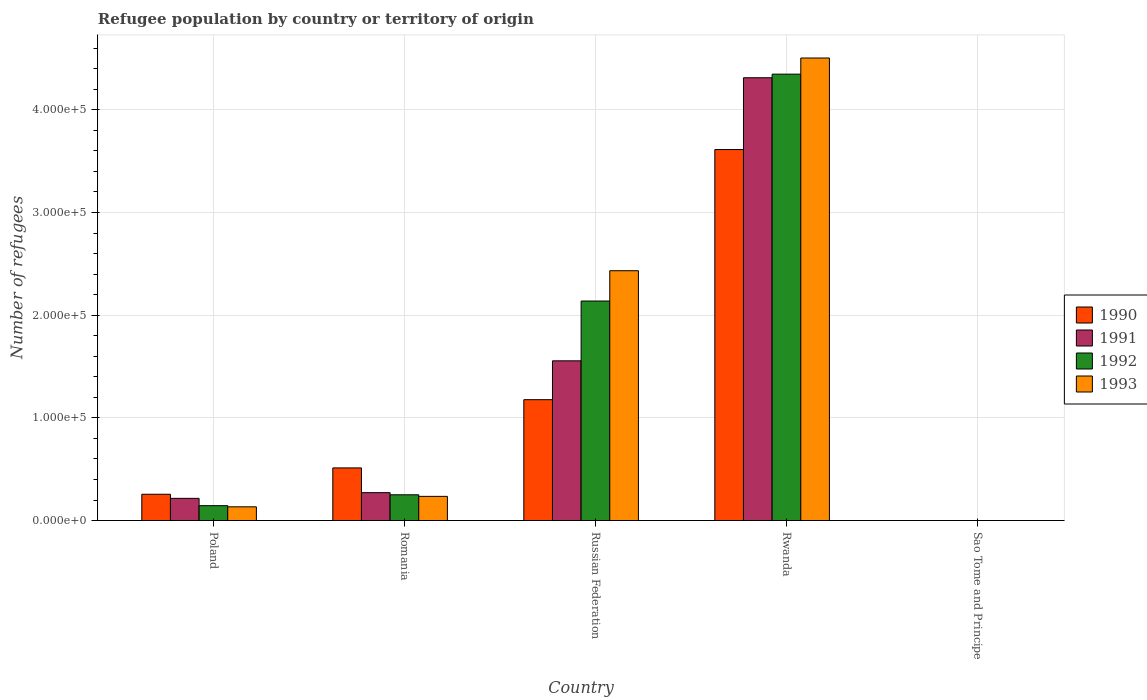How many groups of bars are there?
Your answer should be compact. 5. Are the number of bars on each tick of the X-axis equal?
Offer a terse response. Yes. How many bars are there on the 1st tick from the left?
Offer a terse response. 4. What is the label of the 3rd group of bars from the left?
Offer a very short reply. Russian Federation. In how many cases, is the number of bars for a given country not equal to the number of legend labels?
Offer a terse response. 0. What is the number of refugees in 1992 in Rwanda?
Your response must be concise. 4.35e+05. Across all countries, what is the maximum number of refugees in 1991?
Give a very brief answer. 4.31e+05. Across all countries, what is the minimum number of refugees in 1993?
Make the answer very short. 1. In which country was the number of refugees in 1990 maximum?
Make the answer very short. Rwanda. In which country was the number of refugees in 1992 minimum?
Offer a terse response. Sao Tome and Principe. What is the total number of refugees in 1990 in the graph?
Ensure brevity in your answer.  5.56e+05. What is the difference between the number of refugees in 1992 in Rwanda and that in Sao Tome and Principe?
Give a very brief answer. 4.35e+05. What is the difference between the number of refugees in 1993 in Poland and the number of refugees in 1992 in Sao Tome and Principe?
Your answer should be compact. 1.34e+04. What is the average number of refugees in 1993 per country?
Ensure brevity in your answer.  1.46e+05. What is the difference between the number of refugees of/in 1991 and number of refugees of/in 1990 in Poland?
Keep it short and to the point. -3989. What is the ratio of the number of refugees in 1993 in Poland to that in Sao Tome and Principe?
Your answer should be compact. 1.34e+04. Is the difference between the number of refugees in 1991 in Poland and Rwanda greater than the difference between the number of refugees in 1990 in Poland and Rwanda?
Keep it short and to the point. No. What is the difference between the highest and the second highest number of refugees in 1991?
Offer a very short reply. 4.04e+05. What is the difference between the highest and the lowest number of refugees in 1993?
Your response must be concise. 4.50e+05. In how many countries, is the number of refugees in 1990 greater than the average number of refugees in 1990 taken over all countries?
Provide a short and direct response. 2. What does the 4th bar from the left in Sao Tome and Principe represents?
Provide a short and direct response. 1993. How many bars are there?
Provide a succinct answer. 20. Where does the legend appear in the graph?
Offer a terse response. Center right. How many legend labels are there?
Offer a very short reply. 4. How are the legend labels stacked?
Offer a terse response. Vertical. What is the title of the graph?
Make the answer very short. Refugee population by country or territory of origin. Does "1974" appear as one of the legend labels in the graph?
Your response must be concise. No. What is the label or title of the Y-axis?
Keep it short and to the point. Number of refugees. What is the Number of refugees of 1990 in Poland?
Offer a terse response. 2.56e+04. What is the Number of refugees in 1991 in Poland?
Ensure brevity in your answer.  2.16e+04. What is the Number of refugees in 1992 in Poland?
Your answer should be very brief. 1.45e+04. What is the Number of refugees of 1993 in Poland?
Offer a terse response. 1.34e+04. What is the Number of refugees of 1990 in Romania?
Provide a short and direct response. 5.13e+04. What is the Number of refugees in 1991 in Romania?
Offer a terse response. 2.72e+04. What is the Number of refugees in 1992 in Romania?
Your answer should be compact. 2.51e+04. What is the Number of refugees of 1993 in Romania?
Your answer should be very brief. 2.36e+04. What is the Number of refugees in 1990 in Russian Federation?
Provide a short and direct response. 1.18e+05. What is the Number of refugees of 1991 in Russian Federation?
Provide a short and direct response. 1.56e+05. What is the Number of refugees in 1992 in Russian Federation?
Ensure brevity in your answer.  2.14e+05. What is the Number of refugees of 1993 in Russian Federation?
Offer a very short reply. 2.43e+05. What is the Number of refugees of 1990 in Rwanda?
Your answer should be very brief. 3.61e+05. What is the Number of refugees in 1991 in Rwanda?
Offer a terse response. 4.31e+05. What is the Number of refugees of 1992 in Rwanda?
Give a very brief answer. 4.35e+05. What is the Number of refugees in 1993 in Rwanda?
Make the answer very short. 4.50e+05. What is the Number of refugees in 1991 in Sao Tome and Principe?
Offer a very short reply. 1. What is the Number of refugees in 1992 in Sao Tome and Principe?
Provide a succinct answer. 1. Across all countries, what is the maximum Number of refugees in 1990?
Your response must be concise. 3.61e+05. Across all countries, what is the maximum Number of refugees of 1991?
Make the answer very short. 4.31e+05. Across all countries, what is the maximum Number of refugees in 1992?
Give a very brief answer. 4.35e+05. Across all countries, what is the maximum Number of refugees in 1993?
Your answer should be very brief. 4.50e+05. Across all countries, what is the minimum Number of refugees of 1990?
Your answer should be very brief. 1. Across all countries, what is the minimum Number of refugees in 1991?
Provide a succinct answer. 1. Across all countries, what is the minimum Number of refugees of 1992?
Offer a terse response. 1. What is the total Number of refugees in 1990 in the graph?
Provide a short and direct response. 5.56e+05. What is the total Number of refugees of 1991 in the graph?
Your response must be concise. 6.36e+05. What is the total Number of refugees in 1992 in the graph?
Provide a succinct answer. 6.88e+05. What is the total Number of refugees in 1993 in the graph?
Keep it short and to the point. 7.31e+05. What is the difference between the Number of refugees in 1990 in Poland and that in Romania?
Your response must be concise. -2.56e+04. What is the difference between the Number of refugees of 1991 in Poland and that in Romania?
Provide a short and direct response. -5534. What is the difference between the Number of refugees of 1992 in Poland and that in Romania?
Ensure brevity in your answer.  -1.06e+04. What is the difference between the Number of refugees in 1993 in Poland and that in Romania?
Provide a short and direct response. -1.02e+04. What is the difference between the Number of refugees in 1990 in Poland and that in Russian Federation?
Keep it short and to the point. -9.21e+04. What is the difference between the Number of refugees in 1991 in Poland and that in Russian Federation?
Your response must be concise. -1.34e+05. What is the difference between the Number of refugees of 1992 in Poland and that in Russian Federation?
Provide a short and direct response. -1.99e+05. What is the difference between the Number of refugees in 1993 in Poland and that in Russian Federation?
Your response must be concise. -2.30e+05. What is the difference between the Number of refugees in 1990 in Poland and that in Rwanda?
Provide a short and direct response. -3.36e+05. What is the difference between the Number of refugees of 1991 in Poland and that in Rwanda?
Your answer should be compact. -4.10e+05. What is the difference between the Number of refugees in 1992 in Poland and that in Rwanda?
Offer a very short reply. -4.20e+05. What is the difference between the Number of refugees of 1993 in Poland and that in Rwanda?
Your answer should be compact. -4.37e+05. What is the difference between the Number of refugees of 1990 in Poland and that in Sao Tome and Principe?
Your response must be concise. 2.56e+04. What is the difference between the Number of refugees of 1991 in Poland and that in Sao Tome and Principe?
Keep it short and to the point. 2.16e+04. What is the difference between the Number of refugees of 1992 in Poland and that in Sao Tome and Principe?
Offer a terse response. 1.45e+04. What is the difference between the Number of refugees in 1993 in Poland and that in Sao Tome and Principe?
Offer a terse response. 1.34e+04. What is the difference between the Number of refugees in 1990 in Romania and that in Russian Federation?
Provide a succinct answer. -6.65e+04. What is the difference between the Number of refugees in 1991 in Romania and that in Russian Federation?
Provide a short and direct response. -1.28e+05. What is the difference between the Number of refugees in 1992 in Romania and that in Russian Federation?
Ensure brevity in your answer.  -1.89e+05. What is the difference between the Number of refugees in 1993 in Romania and that in Russian Federation?
Provide a short and direct response. -2.20e+05. What is the difference between the Number of refugees of 1990 in Romania and that in Rwanda?
Your response must be concise. -3.10e+05. What is the difference between the Number of refugees in 1991 in Romania and that in Rwanda?
Provide a short and direct response. -4.04e+05. What is the difference between the Number of refugees of 1992 in Romania and that in Rwanda?
Provide a short and direct response. -4.10e+05. What is the difference between the Number of refugees of 1993 in Romania and that in Rwanda?
Keep it short and to the point. -4.27e+05. What is the difference between the Number of refugees of 1990 in Romania and that in Sao Tome and Principe?
Offer a terse response. 5.13e+04. What is the difference between the Number of refugees in 1991 in Romania and that in Sao Tome and Principe?
Ensure brevity in your answer.  2.72e+04. What is the difference between the Number of refugees of 1992 in Romania and that in Sao Tome and Principe?
Your response must be concise. 2.51e+04. What is the difference between the Number of refugees in 1993 in Romania and that in Sao Tome and Principe?
Make the answer very short. 2.36e+04. What is the difference between the Number of refugees in 1990 in Russian Federation and that in Rwanda?
Ensure brevity in your answer.  -2.44e+05. What is the difference between the Number of refugees in 1991 in Russian Federation and that in Rwanda?
Make the answer very short. -2.76e+05. What is the difference between the Number of refugees in 1992 in Russian Federation and that in Rwanda?
Offer a very short reply. -2.21e+05. What is the difference between the Number of refugees in 1993 in Russian Federation and that in Rwanda?
Offer a very short reply. -2.07e+05. What is the difference between the Number of refugees of 1990 in Russian Federation and that in Sao Tome and Principe?
Your response must be concise. 1.18e+05. What is the difference between the Number of refugees in 1991 in Russian Federation and that in Sao Tome and Principe?
Provide a short and direct response. 1.56e+05. What is the difference between the Number of refugees of 1992 in Russian Federation and that in Sao Tome and Principe?
Make the answer very short. 2.14e+05. What is the difference between the Number of refugees in 1993 in Russian Federation and that in Sao Tome and Principe?
Your response must be concise. 2.43e+05. What is the difference between the Number of refugees in 1990 in Rwanda and that in Sao Tome and Principe?
Offer a terse response. 3.61e+05. What is the difference between the Number of refugees of 1991 in Rwanda and that in Sao Tome and Principe?
Offer a very short reply. 4.31e+05. What is the difference between the Number of refugees in 1992 in Rwanda and that in Sao Tome and Principe?
Your response must be concise. 4.35e+05. What is the difference between the Number of refugees in 1993 in Rwanda and that in Sao Tome and Principe?
Make the answer very short. 4.50e+05. What is the difference between the Number of refugees of 1990 in Poland and the Number of refugees of 1991 in Romania?
Provide a succinct answer. -1545. What is the difference between the Number of refugees of 1990 in Poland and the Number of refugees of 1992 in Romania?
Make the answer very short. 514. What is the difference between the Number of refugees of 1990 in Poland and the Number of refugees of 1993 in Romania?
Keep it short and to the point. 2060. What is the difference between the Number of refugees of 1991 in Poland and the Number of refugees of 1992 in Romania?
Provide a short and direct response. -3475. What is the difference between the Number of refugees of 1991 in Poland and the Number of refugees of 1993 in Romania?
Your answer should be very brief. -1929. What is the difference between the Number of refugees in 1992 in Poland and the Number of refugees in 1993 in Romania?
Provide a short and direct response. -9054. What is the difference between the Number of refugees of 1990 in Poland and the Number of refugees of 1991 in Russian Federation?
Your answer should be compact. -1.30e+05. What is the difference between the Number of refugees of 1990 in Poland and the Number of refugees of 1992 in Russian Federation?
Keep it short and to the point. -1.88e+05. What is the difference between the Number of refugees in 1990 in Poland and the Number of refugees in 1993 in Russian Federation?
Offer a very short reply. -2.18e+05. What is the difference between the Number of refugees of 1991 in Poland and the Number of refugees of 1992 in Russian Federation?
Ensure brevity in your answer.  -1.92e+05. What is the difference between the Number of refugees of 1991 in Poland and the Number of refugees of 1993 in Russian Federation?
Keep it short and to the point. -2.22e+05. What is the difference between the Number of refugees of 1992 in Poland and the Number of refugees of 1993 in Russian Federation?
Your answer should be compact. -2.29e+05. What is the difference between the Number of refugees of 1990 in Poland and the Number of refugees of 1991 in Rwanda?
Offer a terse response. -4.06e+05. What is the difference between the Number of refugees of 1990 in Poland and the Number of refugees of 1992 in Rwanda?
Offer a very short reply. -4.09e+05. What is the difference between the Number of refugees of 1990 in Poland and the Number of refugees of 1993 in Rwanda?
Offer a terse response. -4.25e+05. What is the difference between the Number of refugees of 1991 in Poland and the Number of refugees of 1992 in Rwanda?
Give a very brief answer. -4.13e+05. What is the difference between the Number of refugees of 1991 in Poland and the Number of refugees of 1993 in Rwanda?
Your answer should be very brief. -4.29e+05. What is the difference between the Number of refugees of 1992 in Poland and the Number of refugees of 1993 in Rwanda?
Give a very brief answer. -4.36e+05. What is the difference between the Number of refugees of 1990 in Poland and the Number of refugees of 1991 in Sao Tome and Principe?
Your answer should be compact. 2.56e+04. What is the difference between the Number of refugees of 1990 in Poland and the Number of refugees of 1992 in Sao Tome and Principe?
Your answer should be compact. 2.56e+04. What is the difference between the Number of refugees in 1990 in Poland and the Number of refugees in 1993 in Sao Tome and Principe?
Provide a succinct answer. 2.56e+04. What is the difference between the Number of refugees of 1991 in Poland and the Number of refugees of 1992 in Sao Tome and Principe?
Offer a very short reply. 2.16e+04. What is the difference between the Number of refugees in 1991 in Poland and the Number of refugees in 1993 in Sao Tome and Principe?
Keep it short and to the point. 2.16e+04. What is the difference between the Number of refugees of 1992 in Poland and the Number of refugees of 1993 in Sao Tome and Principe?
Keep it short and to the point. 1.45e+04. What is the difference between the Number of refugees of 1990 in Romania and the Number of refugees of 1991 in Russian Federation?
Your response must be concise. -1.04e+05. What is the difference between the Number of refugees in 1990 in Romania and the Number of refugees in 1992 in Russian Federation?
Give a very brief answer. -1.63e+05. What is the difference between the Number of refugees in 1990 in Romania and the Number of refugees in 1993 in Russian Federation?
Provide a short and direct response. -1.92e+05. What is the difference between the Number of refugees in 1991 in Romania and the Number of refugees in 1992 in Russian Federation?
Offer a terse response. -1.87e+05. What is the difference between the Number of refugees of 1991 in Romania and the Number of refugees of 1993 in Russian Federation?
Your answer should be very brief. -2.16e+05. What is the difference between the Number of refugees of 1992 in Romania and the Number of refugees of 1993 in Russian Federation?
Provide a succinct answer. -2.18e+05. What is the difference between the Number of refugees in 1990 in Romania and the Number of refugees in 1991 in Rwanda?
Ensure brevity in your answer.  -3.80e+05. What is the difference between the Number of refugees in 1990 in Romania and the Number of refugees in 1992 in Rwanda?
Your answer should be very brief. -3.83e+05. What is the difference between the Number of refugees in 1990 in Romania and the Number of refugees in 1993 in Rwanda?
Offer a terse response. -3.99e+05. What is the difference between the Number of refugees of 1991 in Romania and the Number of refugees of 1992 in Rwanda?
Your response must be concise. -4.08e+05. What is the difference between the Number of refugees in 1991 in Romania and the Number of refugees in 1993 in Rwanda?
Provide a short and direct response. -4.23e+05. What is the difference between the Number of refugees of 1992 in Romania and the Number of refugees of 1993 in Rwanda?
Your answer should be very brief. -4.25e+05. What is the difference between the Number of refugees in 1990 in Romania and the Number of refugees in 1991 in Sao Tome and Principe?
Make the answer very short. 5.13e+04. What is the difference between the Number of refugees in 1990 in Romania and the Number of refugees in 1992 in Sao Tome and Principe?
Offer a very short reply. 5.13e+04. What is the difference between the Number of refugees in 1990 in Romania and the Number of refugees in 1993 in Sao Tome and Principe?
Give a very brief answer. 5.13e+04. What is the difference between the Number of refugees of 1991 in Romania and the Number of refugees of 1992 in Sao Tome and Principe?
Give a very brief answer. 2.72e+04. What is the difference between the Number of refugees of 1991 in Romania and the Number of refugees of 1993 in Sao Tome and Principe?
Offer a terse response. 2.72e+04. What is the difference between the Number of refugees of 1992 in Romania and the Number of refugees of 1993 in Sao Tome and Principe?
Provide a succinct answer. 2.51e+04. What is the difference between the Number of refugees in 1990 in Russian Federation and the Number of refugees in 1991 in Rwanda?
Ensure brevity in your answer.  -3.14e+05. What is the difference between the Number of refugees of 1990 in Russian Federation and the Number of refugees of 1992 in Rwanda?
Provide a short and direct response. -3.17e+05. What is the difference between the Number of refugees in 1990 in Russian Federation and the Number of refugees in 1993 in Rwanda?
Offer a terse response. -3.33e+05. What is the difference between the Number of refugees of 1991 in Russian Federation and the Number of refugees of 1992 in Rwanda?
Provide a short and direct response. -2.79e+05. What is the difference between the Number of refugees of 1991 in Russian Federation and the Number of refugees of 1993 in Rwanda?
Ensure brevity in your answer.  -2.95e+05. What is the difference between the Number of refugees in 1992 in Russian Federation and the Number of refugees in 1993 in Rwanda?
Give a very brief answer. -2.37e+05. What is the difference between the Number of refugees of 1990 in Russian Federation and the Number of refugees of 1991 in Sao Tome and Principe?
Your response must be concise. 1.18e+05. What is the difference between the Number of refugees of 1990 in Russian Federation and the Number of refugees of 1992 in Sao Tome and Principe?
Your answer should be very brief. 1.18e+05. What is the difference between the Number of refugees in 1990 in Russian Federation and the Number of refugees in 1993 in Sao Tome and Principe?
Provide a short and direct response. 1.18e+05. What is the difference between the Number of refugees in 1991 in Russian Federation and the Number of refugees in 1992 in Sao Tome and Principe?
Give a very brief answer. 1.56e+05. What is the difference between the Number of refugees in 1991 in Russian Federation and the Number of refugees in 1993 in Sao Tome and Principe?
Keep it short and to the point. 1.56e+05. What is the difference between the Number of refugees in 1992 in Russian Federation and the Number of refugees in 1993 in Sao Tome and Principe?
Ensure brevity in your answer.  2.14e+05. What is the difference between the Number of refugees of 1990 in Rwanda and the Number of refugees of 1991 in Sao Tome and Principe?
Keep it short and to the point. 3.61e+05. What is the difference between the Number of refugees in 1990 in Rwanda and the Number of refugees in 1992 in Sao Tome and Principe?
Your response must be concise. 3.61e+05. What is the difference between the Number of refugees in 1990 in Rwanda and the Number of refugees in 1993 in Sao Tome and Principe?
Offer a terse response. 3.61e+05. What is the difference between the Number of refugees in 1991 in Rwanda and the Number of refugees in 1992 in Sao Tome and Principe?
Your answer should be very brief. 4.31e+05. What is the difference between the Number of refugees in 1991 in Rwanda and the Number of refugees in 1993 in Sao Tome and Principe?
Your answer should be very brief. 4.31e+05. What is the difference between the Number of refugees of 1992 in Rwanda and the Number of refugees of 1993 in Sao Tome and Principe?
Your answer should be very brief. 4.35e+05. What is the average Number of refugees in 1990 per country?
Provide a succinct answer. 1.11e+05. What is the average Number of refugees of 1991 per country?
Provide a short and direct response. 1.27e+05. What is the average Number of refugees in 1992 per country?
Keep it short and to the point. 1.38e+05. What is the average Number of refugees of 1993 per country?
Offer a terse response. 1.46e+05. What is the difference between the Number of refugees in 1990 and Number of refugees in 1991 in Poland?
Make the answer very short. 3989. What is the difference between the Number of refugees of 1990 and Number of refugees of 1992 in Poland?
Your response must be concise. 1.11e+04. What is the difference between the Number of refugees of 1990 and Number of refugees of 1993 in Poland?
Offer a terse response. 1.22e+04. What is the difference between the Number of refugees of 1991 and Number of refugees of 1992 in Poland?
Ensure brevity in your answer.  7125. What is the difference between the Number of refugees in 1991 and Number of refugees in 1993 in Poland?
Your response must be concise. 8253. What is the difference between the Number of refugees in 1992 and Number of refugees in 1993 in Poland?
Your answer should be very brief. 1128. What is the difference between the Number of refugees in 1990 and Number of refugees in 1991 in Romania?
Make the answer very short. 2.41e+04. What is the difference between the Number of refugees in 1990 and Number of refugees in 1992 in Romania?
Provide a succinct answer. 2.62e+04. What is the difference between the Number of refugees of 1990 and Number of refugees of 1993 in Romania?
Your response must be concise. 2.77e+04. What is the difference between the Number of refugees in 1991 and Number of refugees in 1992 in Romania?
Your answer should be compact. 2059. What is the difference between the Number of refugees of 1991 and Number of refugees of 1993 in Romania?
Provide a succinct answer. 3605. What is the difference between the Number of refugees in 1992 and Number of refugees in 1993 in Romania?
Provide a short and direct response. 1546. What is the difference between the Number of refugees in 1990 and Number of refugees in 1991 in Russian Federation?
Your answer should be compact. -3.78e+04. What is the difference between the Number of refugees in 1990 and Number of refugees in 1992 in Russian Federation?
Make the answer very short. -9.61e+04. What is the difference between the Number of refugees in 1990 and Number of refugees in 1993 in Russian Federation?
Give a very brief answer. -1.26e+05. What is the difference between the Number of refugees of 1991 and Number of refugees of 1992 in Russian Federation?
Your response must be concise. -5.82e+04. What is the difference between the Number of refugees of 1991 and Number of refugees of 1993 in Russian Federation?
Provide a short and direct response. -8.77e+04. What is the difference between the Number of refugees of 1992 and Number of refugees of 1993 in Russian Federation?
Offer a very short reply. -2.95e+04. What is the difference between the Number of refugees in 1990 and Number of refugees in 1991 in Rwanda?
Your answer should be compact. -6.99e+04. What is the difference between the Number of refugees of 1990 and Number of refugees of 1992 in Rwanda?
Ensure brevity in your answer.  -7.34e+04. What is the difference between the Number of refugees of 1990 and Number of refugees of 1993 in Rwanda?
Your answer should be compact. -8.91e+04. What is the difference between the Number of refugees in 1991 and Number of refugees in 1992 in Rwanda?
Your response must be concise. -3496. What is the difference between the Number of refugees of 1991 and Number of refugees of 1993 in Rwanda?
Provide a succinct answer. -1.92e+04. What is the difference between the Number of refugees in 1992 and Number of refugees in 1993 in Rwanda?
Your answer should be compact. -1.57e+04. What is the difference between the Number of refugees of 1991 and Number of refugees of 1992 in Sao Tome and Principe?
Your answer should be very brief. 0. What is the difference between the Number of refugees of 1991 and Number of refugees of 1993 in Sao Tome and Principe?
Your answer should be very brief. 0. What is the difference between the Number of refugees of 1992 and Number of refugees of 1993 in Sao Tome and Principe?
Keep it short and to the point. 0. What is the ratio of the Number of refugees in 1990 in Poland to that in Romania?
Ensure brevity in your answer.  0.5. What is the ratio of the Number of refugees of 1991 in Poland to that in Romania?
Your answer should be compact. 0.8. What is the ratio of the Number of refugees of 1992 in Poland to that in Romania?
Your response must be concise. 0.58. What is the ratio of the Number of refugees of 1993 in Poland to that in Romania?
Provide a succinct answer. 0.57. What is the ratio of the Number of refugees in 1990 in Poland to that in Russian Federation?
Your answer should be compact. 0.22. What is the ratio of the Number of refugees in 1991 in Poland to that in Russian Federation?
Make the answer very short. 0.14. What is the ratio of the Number of refugees of 1992 in Poland to that in Russian Federation?
Make the answer very short. 0.07. What is the ratio of the Number of refugees of 1993 in Poland to that in Russian Federation?
Your response must be concise. 0.06. What is the ratio of the Number of refugees in 1990 in Poland to that in Rwanda?
Your answer should be compact. 0.07. What is the ratio of the Number of refugees of 1991 in Poland to that in Rwanda?
Offer a terse response. 0.05. What is the ratio of the Number of refugees in 1992 in Poland to that in Rwanda?
Your answer should be very brief. 0.03. What is the ratio of the Number of refugees in 1993 in Poland to that in Rwanda?
Your answer should be compact. 0.03. What is the ratio of the Number of refugees in 1990 in Poland to that in Sao Tome and Principe?
Your answer should be compact. 2.56e+04. What is the ratio of the Number of refugees in 1991 in Poland to that in Sao Tome and Principe?
Your answer should be very brief. 2.16e+04. What is the ratio of the Number of refugees of 1992 in Poland to that in Sao Tome and Principe?
Offer a very short reply. 1.45e+04. What is the ratio of the Number of refugees in 1993 in Poland to that in Sao Tome and Principe?
Your answer should be very brief. 1.34e+04. What is the ratio of the Number of refugees of 1990 in Romania to that in Russian Federation?
Keep it short and to the point. 0.44. What is the ratio of the Number of refugees in 1991 in Romania to that in Russian Federation?
Provide a short and direct response. 0.17. What is the ratio of the Number of refugees of 1992 in Romania to that in Russian Federation?
Offer a terse response. 0.12. What is the ratio of the Number of refugees of 1993 in Romania to that in Russian Federation?
Your answer should be very brief. 0.1. What is the ratio of the Number of refugees of 1990 in Romania to that in Rwanda?
Your answer should be very brief. 0.14. What is the ratio of the Number of refugees in 1991 in Romania to that in Rwanda?
Offer a very short reply. 0.06. What is the ratio of the Number of refugees in 1992 in Romania to that in Rwanda?
Make the answer very short. 0.06. What is the ratio of the Number of refugees of 1993 in Romania to that in Rwanda?
Keep it short and to the point. 0.05. What is the ratio of the Number of refugees of 1990 in Romania to that in Sao Tome and Principe?
Your answer should be compact. 5.13e+04. What is the ratio of the Number of refugees in 1991 in Romania to that in Sao Tome and Principe?
Offer a very short reply. 2.72e+04. What is the ratio of the Number of refugees of 1992 in Romania to that in Sao Tome and Principe?
Ensure brevity in your answer.  2.51e+04. What is the ratio of the Number of refugees in 1993 in Romania to that in Sao Tome and Principe?
Provide a short and direct response. 2.36e+04. What is the ratio of the Number of refugees of 1990 in Russian Federation to that in Rwanda?
Keep it short and to the point. 0.33. What is the ratio of the Number of refugees of 1991 in Russian Federation to that in Rwanda?
Offer a terse response. 0.36. What is the ratio of the Number of refugees of 1992 in Russian Federation to that in Rwanda?
Make the answer very short. 0.49. What is the ratio of the Number of refugees of 1993 in Russian Federation to that in Rwanda?
Your answer should be very brief. 0.54. What is the ratio of the Number of refugees in 1990 in Russian Federation to that in Sao Tome and Principe?
Offer a very short reply. 1.18e+05. What is the ratio of the Number of refugees of 1991 in Russian Federation to that in Sao Tome and Principe?
Your response must be concise. 1.56e+05. What is the ratio of the Number of refugees of 1992 in Russian Federation to that in Sao Tome and Principe?
Provide a succinct answer. 2.14e+05. What is the ratio of the Number of refugees of 1993 in Russian Federation to that in Sao Tome and Principe?
Your answer should be very brief. 2.43e+05. What is the ratio of the Number of refugees of 1990 in Rwanda to that in Sao Tome and Principe?
Make the answer very short. 3.61e+05. What is the ratio of the Number of refugees in 1991 in Rwanda to that in Sao Tome and Principe?
Ensure brevity in your answer.  4.31e+05. What is the ratio of the Number of refugees in 1992 in Rwanda to that in Sao Tome and Principe?
Give a very brief answer. 4.35e+05. What is the ratio of the Number of refugees in 1993 in Rwanda to that in Sao Tome and Principe?
Offer a terse response. 4.50e+05. What is the difference between the highest and the second highest Number of refugees in 1990?
Make the answer very short. 2.44e+05. What is the difference between the highest and the second highest Number of refugees of 1991?
Provide a short and direct response. 2.76e+05. What is the difference between the highest and the second highest Number of refugees in 1992?
Offer a very short reply. 2.21e+05. What is the difference between the highest and the second highest Number of refugees in 1993?
Ensure brevity in your answer.  2.07e+05. What is the difference between the highest and the lowest Number of refugees of 1990?
Your answer should be compact. 3.61e+05. What is the difference between the highest and the lowest Number of refugees in 1991?
Offer a very short reply. 4.31e+05. What is the difference between the highest and the lowest Number of refugees in 1992?
Give a very brief answer. 4.35e+05. What is the difference between the highest and the lowest Number of refugees in 1993?
Your answer should be compact. 4.50e+05. 